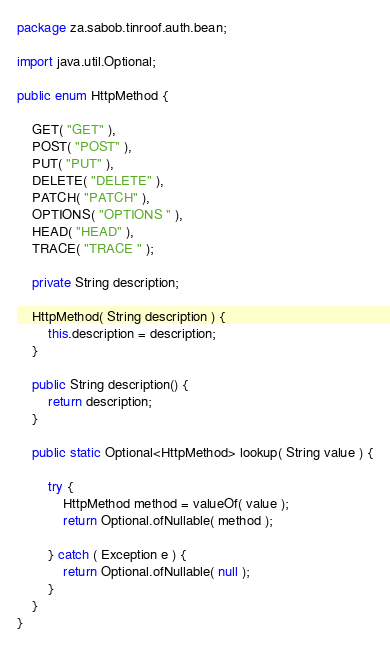Convert code to text. <code><loc_0><loc_0><loc_500><loc_500><_Java_>package za.sabob.tinroof.auth.bean;

import java.util.Optional;

public enum HttpMethod {

    GET( "GET" ),
    POST( "POST" ),
    PUT( "PUT" ),
    DELETE( "DELETE" ),
    PATCH( "PATCH" ),
    OPTIONS( "OPTIONS " ),
    HEAD( "HEAD" ),
    TRACE( "TRACE " );

    private String description;

    HttpMethod( String description ) {
        this.description = description;
    }

    public String description() {
        return description;
    }

    public static Optional<HttpMethod> lookup( String value ) {

        try {
            HttpMethod method = valueOf( value );
            return Optional.ofNullable( method );

        } catch ( Exception e ) {
            return Optional.ofNullable( null );
        }
    }
}
</code> 